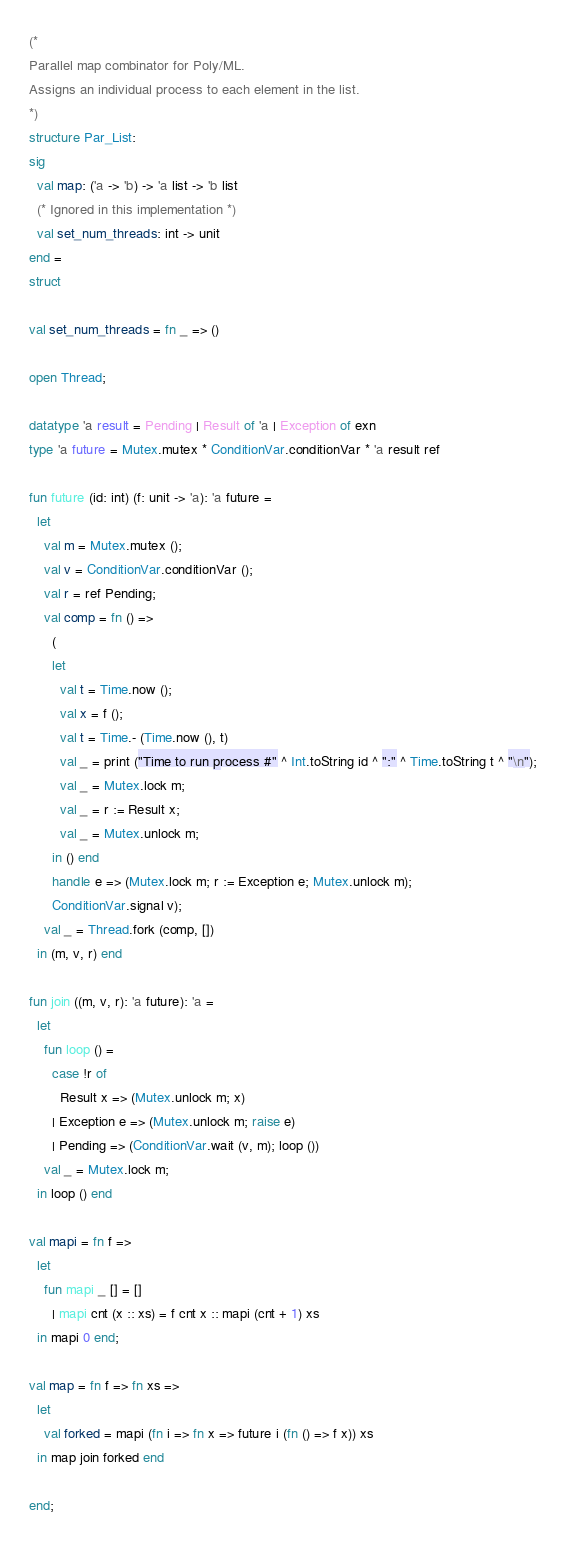<code> <loc_0><loc_0><loc_500><loc_500><_SML_>(*
Parallel map combinator for Poly/ML.
Assigns an individual process to each element in the list.
*)
structure Par_List:
sig
  val map: ('a -> 'b) -> 'a list -> 'b list
  (* Ignored in this implementation *)
  val set_num_threads: int -> unit
end =
struct

val set_num_threads = fn _ => ()

open Thread;

datatype 'a result = Pending | Result of 'a | Exception of exn
type 'a future = Mutex.mutex * ConditionVar.conditionVar * 'a result ref

fun future (id: int) (f: unit -> 'a): 'a future =
  let
    val m = Mutex.mutex ();
    val v = ConditionVar.conditionVar ();
    val r = ref Pending;
    val comp = fn () =>
      (
      let
        val t = Time.now ();
        val x = f ();
        val t = Time.- (Time.now (), t)
        val _ = print ("Time to run process #" ^ Int.toString id ^ ":" ^ Time.toString t ^ "\n");
        val _ = Mutex.lock m;
        val _ = r := Result x;
        val _ = Mutex.unlock m;
      in () end
      handle e => (Mutex.lock m; r := Exception e; Mutex.unlock m);
      ConditionVar.signal v);
    val _ = Thread.fork (comp, [])
  in (m, v, r) end

fun join ((m, v, r): 'a future): 'a =
  let
    fun loop () =
      case !r of
        Result x => (Mutex.unlock m; x)
      | Exception e => (Mutex.unlock m; raise e)
      | Pending => (ConditionVar.wait (v, m); loop ())
    val _ = Mutex.lock m;
  in loop () end

val mapi = fn f =>
  let
    fun mapi _ [] = []
      | mapi cnt (x :: xs) = f cnt x :: mapi (cnt + 1) xs
  in mapi 0 end;

val map = fn f => fn xs =>
  let
    val forked = mapi (fn i => fn x => future i (fn () => f x)) xs
  in map join forked end

end;</code> 